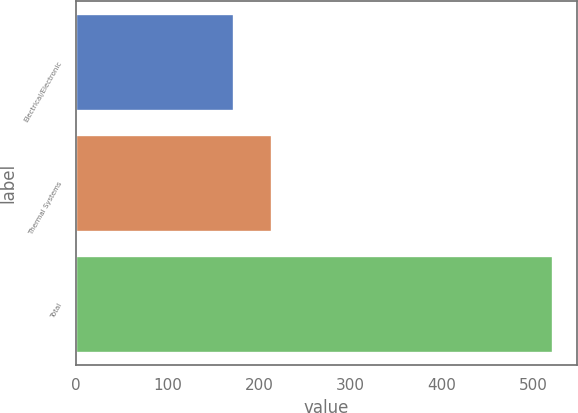Convert chart. <chart><loc_0><loc_0><loc_500><loc_500><bar_chart><fcel>Electrical/Electronic<fcel>Thermal Systems<fcel>Total<nl><fcel>173<fcel>214<fcel>522<nl></chart> 